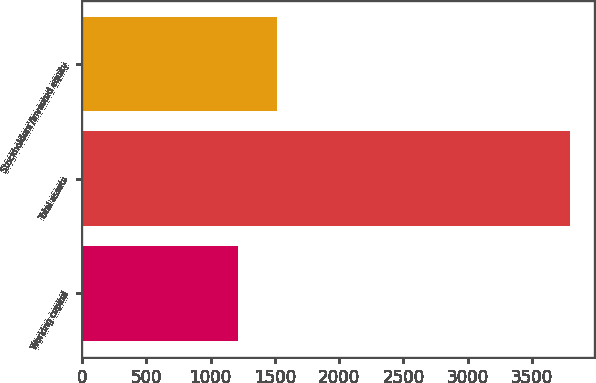Convert chart. <chart><loc_0><loc_0><loc_500><loc_500><bar_chart><fcel>Working capital<fcel>Total assets<fcel>Stockholders'/Invested equity<nl><fcel>1210<fcel>3796<fcel>1513<nl></chart> 